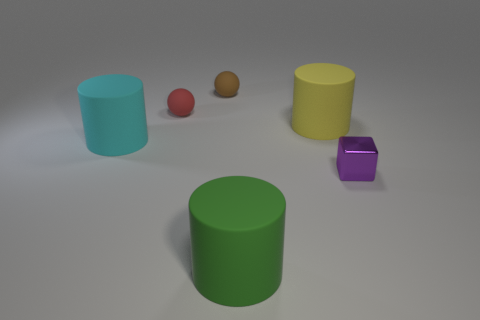Is there any other thing that is the same material as the purple cube?
Offer a terse response. No. How many things are tiny purple shiny blocks or large cylinders right of the cyan cylinder?
Make the answer very short. 3. Are there the same number of tiny red matte things that are on the right side of the big green matte cylinder and big gray rubber objects?
Provide a succinct answer. Yes. There is a tiny red object that is made of the same material as the big yellow cylinder; what shape is it?
Keep it short and to the point. Sphere. How many metallic things are small red things or brown objects?
Make the answer very short. 0. There is a cylinder that is behind the large cyan matte object; how many big yellow cylinders are on the right side of it?
Give a very brief answer. 0. What number of yellow objects have the same material as the brown sphere?
Offer a very short reply. 1. How many small things are either matte balls or red matte balls?
Your answer should be very brief. 2. What shape is the tiny thing that is both right of the tiny red ball and on the left side of the tiny purple thing?
Keep it short and to the point. Sphere. Do the yellow cylinder and the red thing have the same material?
Offer a very short reply. Yes. 